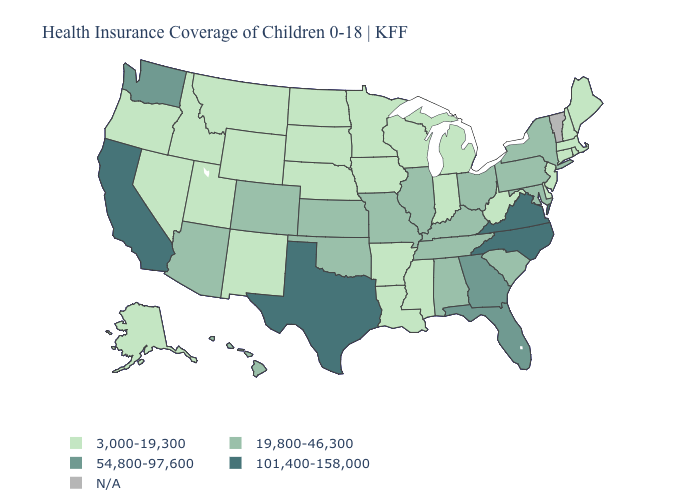What is the value of New Mexico?
Short answer required. 3,000-19,300. Which states have the lowest value in the Northeast?
Keep it brief. Connecticut, Maine, Massachusetts, New Hampshire, New Jersey, Rhode Island. Does the map have missing data?
Write a very short answer. Yes. Name the states that have a value in the range 3,000-19,300?
Short answer required. Alaska, Arkansas, Connecticut, Delaware, Idaho, Indiana, Iowa, Louisiana, Maine, Massachusetts, Michigan, Minnesota, Mississippi, Montana, Nebraska, Nevada, New Hampshire, New Jersey, New Mexico, North Dakota, Oregon, Rhode Island, South Dakota, Utah, West Virginia, Wisconsin, Wyoming. Among the states that border New Jersey , which have the highest value?
Be succinct. New York, Pennsylvania. What is the value of Tennessee?
Quick response, please. 19,800-46,300. What is the value of South Carolina?
Answer briefly. 19,800-46,300. What is the lowest value in the West?
Short answer required. 3,000-19,300. Does Ohio have the highest value in the MidWest?
Write a very short answer. Yes. What is the value of North Dakota?
Answer briefly. 3,000-19,300. Name the states that have a value in the range 101,400-158,000?
Answer briefly. California, North Carolina, Texas, Virginia. What is the highest value in states that border Arkansas?
Write a very short answer. 101,400-158,000. Does the map have missing data?
Keep it brief. Yes. 